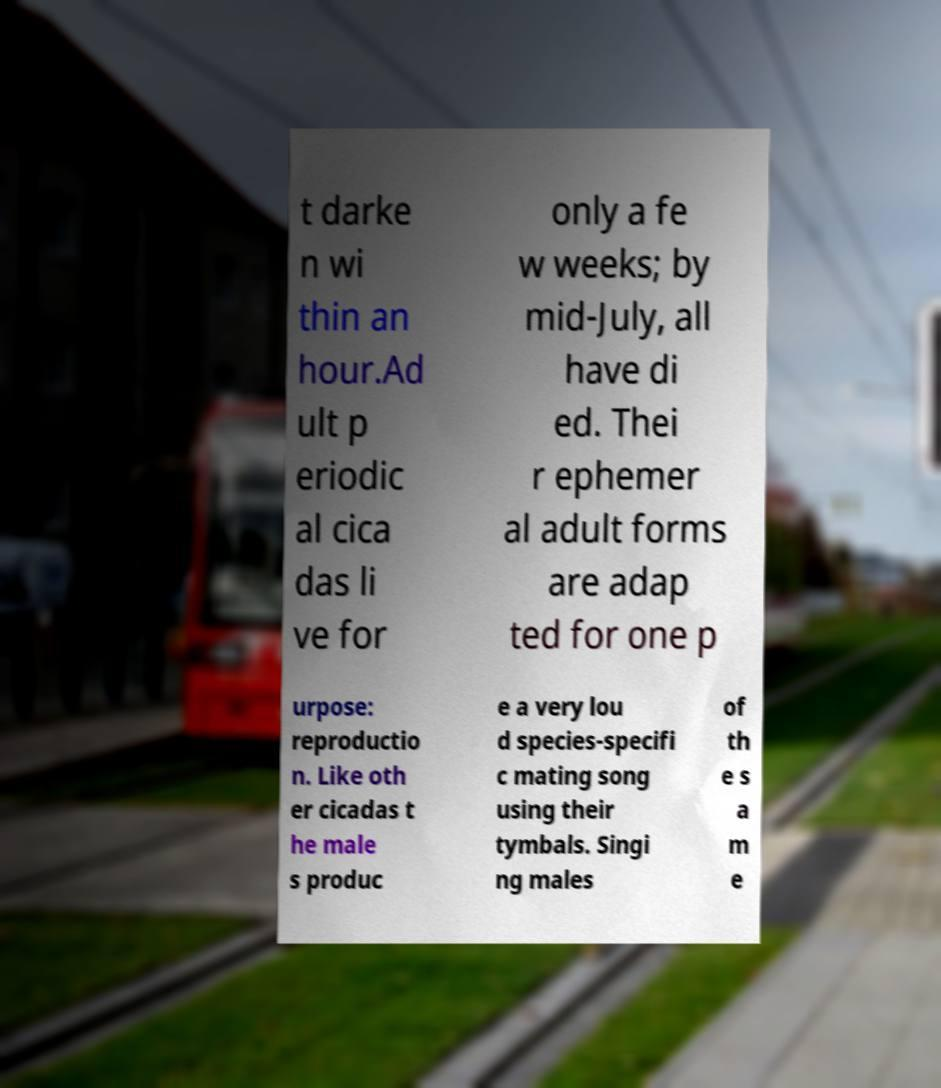Can you read and provide the text displayed in the image?This photo seems to have some interesting text. Can you extract and type it out for me? t darke n wi thin an hour.Ad ult p eriodic al cica das li ve for only a fe w weeks; by mid-July, all have di ed. Thei r ephemer al adult forms are adap ted for one p urpose: reproductio n. Like oth er cicadas t he male s produc e a very lou d species-specifi c mating song using their tymbals. Singi ng males of th e s a m e 